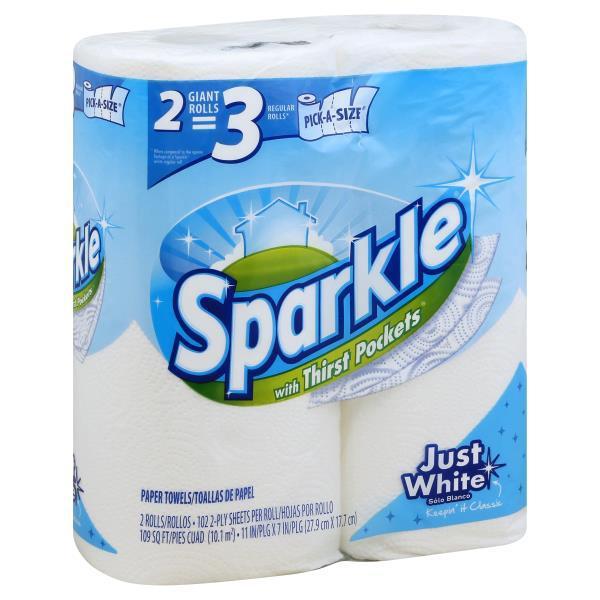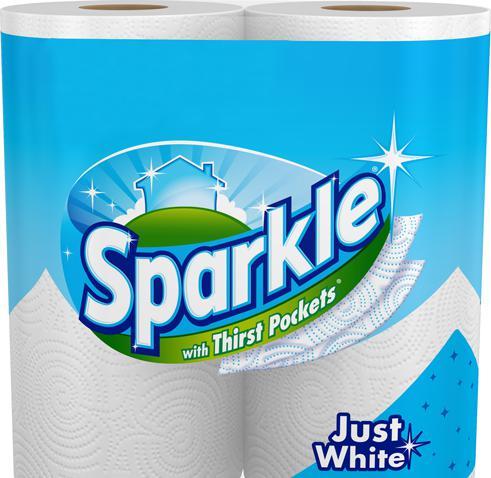The first image is the image on the left, the second image is the image on the right. Evaluate the accuracy of this statement regarding the images: "There are six rolls of paper towel in the package in the image on the left.". Is it true? Answer yes or no. No. The first image is the image on the left, the second image is the image on the right. Evaluate the accuracy of this statement regarding the images: "One image features a single package of six rolls in two rows of three.". Is it true? Answer yes or no. No. 